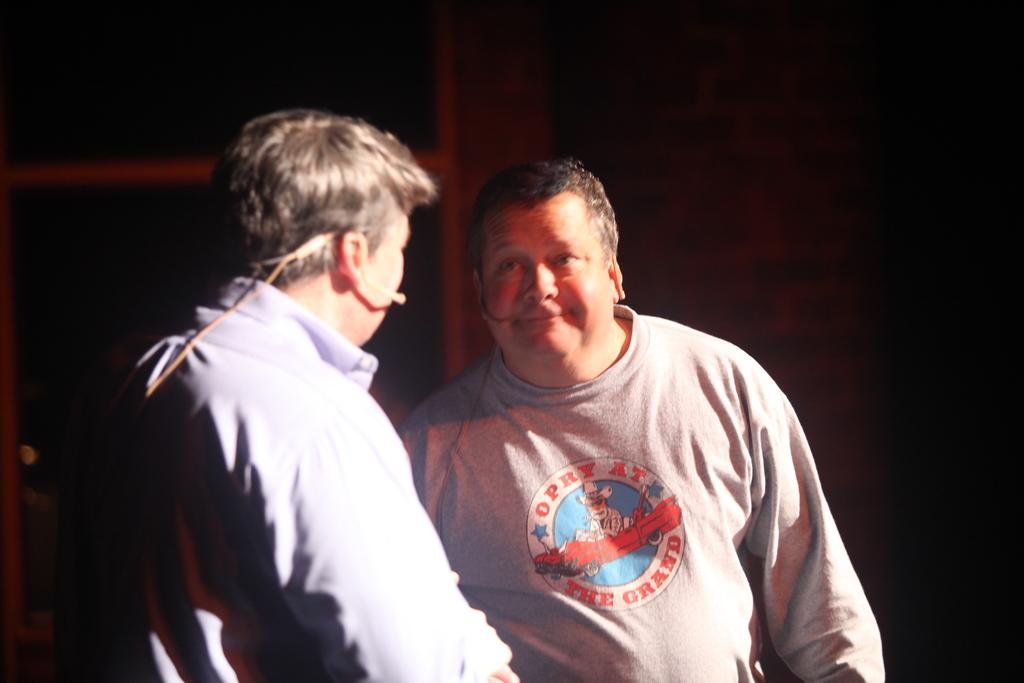How many people are in the image? There are two people standing in the image. What can be observed about the background of the image? The background of the image is dark. What type of destruction can be seen in the image? There is no destruction present in the image; it features two people standing in a dark background. 